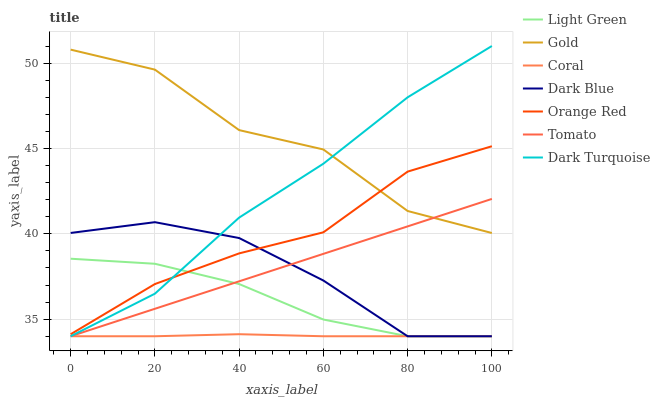Does Coral have the minimum area under the curve?
Answer yes or no. Yes. Does Gold have the maximum area under the curve?
Answer yes or no. Yes. Does Dark Turquoise have the minimum area under the curve?
Answer yes or no. No. Does Dark Turquoise have the maximum area under the curve?
Answer yes or no. No. Is Tomato the smoothest?
Answer yes or no. Yes. Is Gold the roughest?
Answer yes or no. Yes. Is Dark Turquoise the smoothest?
Answer yes or no. No. Is Dark Turquoise the roughest?
Answer yes or no. No. Does Tomato have the lowest value?
Answer yes or no. Yes. Does Gold have the lowest value?
Answer yes or no. No. Does Dark Turquoise have the highest value?
Answer yes or no. Yes. Does Gold have the highest value?
Answer yes or no. No. Is Coral less than Gold?
Answer yes or no. Yes. Is Gold greater than Coral?
Answer yes or no. Yes. Does Tomato intersect Light Green?
Answer yes or no. Yes. Is Tomato less than Light Green?
Answer yes or no. No. Is Tomato greater than Light Green?
Answer yes or no. No. Does Coral intersect Gold?
Answer yes or no. No. 